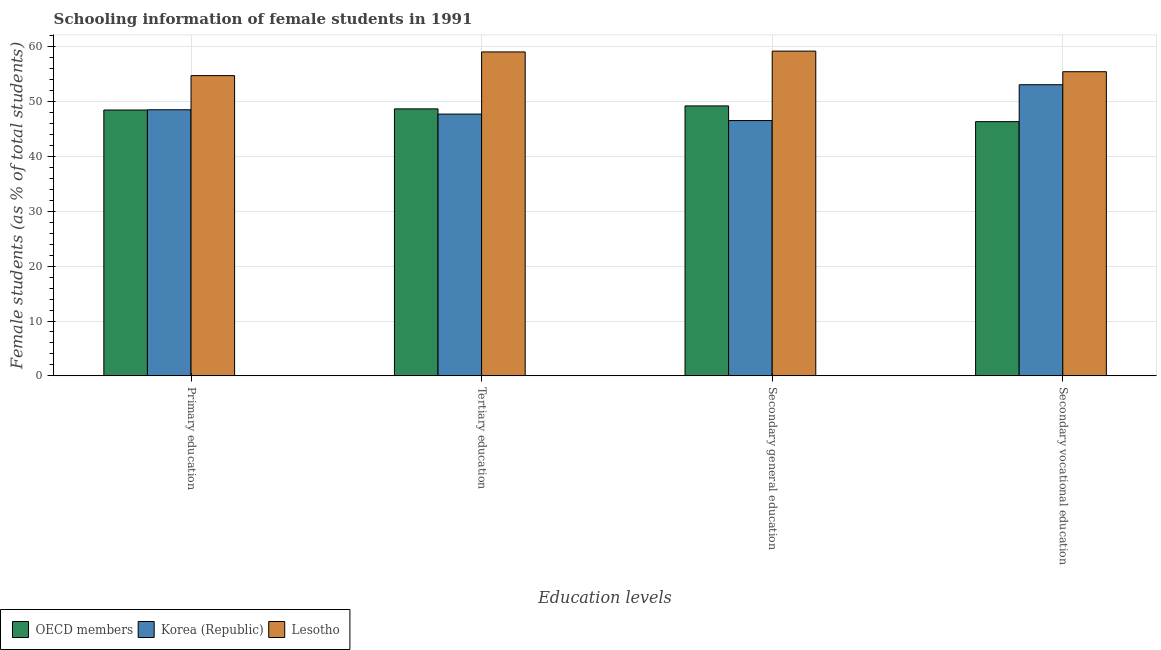How many different coloured bars are there?
Offer a terse response. 3. How many groups of bars are there?
Keep it short and to the point. 4. What is the label of the 1st group of bars from the left?
Keep it short and to the point. Primary education. What is the percentage of female students in secondary vocational education in Korea (Republic)?
Provide a succinct answer. 53.09. Across all countries, what is the maximum percentage of female students in secondary vocational education?
Make the answer very short. 55.46. Across all countries, what is the minimum percentage of female students in primary education?
Keep it short and to the point. 48.48. In which country was the percentage of female students in secondary vocational education maximum?
Offer a very short reply. Lesotho. What is the total percentage of female students in secondary education in the graph?
Provide a succinct answer. 154.99. What is the difference between the percentage of female students in primary education in OECD members and that in Lesotho?
Provide a succinct answer. -6.27. What is the difference between the percentage of female students in secondary education in OECD members and the percentage of female students in tertiary education in Korea (Republic)?
Your answer should be compact. 1.49. What is the average percentage of female students in secondary education per country?
Make the answer very short. 51.66. What is the difference between the percentage of female students in primary education and percentage of female students in tertiary education in OECD members?
Provide a succinct answer. -0.2. What is the ratio of the percentage of female students in tertiary education in Lesotho to that in OECD members?
Your answer should be compact. 1.21. Is the percentage of female students in primary education in OECD members less than that in Korea (Republic)?
Keep it short and to the point. Yes. What is the difference between the highest and the second highest percentage of female students in secondary vocational education?
Offer a very short reply. 2.37. What is the difference between the highest and the lowest percentage of female students in primary education?
Your response must be concise. 6.27. In how many countries, is the percentage of female students in primary education greater than the average percentage of female students in primary education taken over all countries?
Offer a very short reply. 1. Is the sum of the percentage of female students in secondary education in OECD members and Korea (Republic) greater than the maximum percentage of female students in tertiary education across all countries?
Make the answer very short. Yes. Is it the case that in every country, the sum of the percentage of female students in primary education and percentage of female students in secondary education is greater than the sum of percentage of female students in secondary vocational education and percentage of female students in tertiary education?
Provide a short and direct response. No. What does the 3rd bar from the left in Secondary general education represents?
Your response must be concise. Lesotho. What does the 2nd bar from the right in Secondary general education represents?
Provide a short and direct response. Korea (Republic). Is it the case that in every country, the sum of the percentage of female students in primary education and percentage of female students in tertiary education is greater than the percentage of female students in secondary education?
Provide a short and direct response. Yes. Are all the bars in the graph horizontal?
Provide a short and direct response. No. How many countries are there in the graph?
Your answer should be compact. 3. Where does the legend appear in the graph?
Make the answer very short. Bottom left. How are the legend labels stacked?
Your response must be concise. Horizontal. What is the title of the graph?
Your response must be concise. Schooling information of female students in 1991. What is the label or title of the X-axis?
Offer a very short reply. Education levels. What is the label or title of the Y-axis?
Make the answer very short. Female students (as % of total students). What is the Female students (as % of total students) in OECD members in Primary education?
Make the answer very short. 48.48. What is the Female students (as % of total students) of Korea (Republic) in Primary education?
Make the answer very short. 48.52. What is the Female students (as % of total students) of Lesotho in Primary education?
Ensure brevity in your answer.  54.75. What is the Female students (as % of total students) in OECD members in Tertiary education?
Offer a very short reply. 48.68. What is the Female students (as % of total students) in Korea (Republic) in Tertiary education?
Give a very brief answer. 47.73. What is the Female students (as % of total students) in Lesotho in Tertiary education?
Give a very brief answer. 59.06. What is the Female students (as % of total students) in OECD members in Secondary general education?
Make the answer very short. 49.22. What is the Female students (as % of total students) in Korea (Republic) in Secondary general education?
Offer a very short reply. 46.55. What is the Female students (as % of total students) of Lesotho in Secondary general education?
Provide a succinct answer. 59.21. What is the Female students (as % of total students) of OECD members in Secondary vocational education?
Keep it short and to the point. 46.35. What is the Female students (as % of total students) in Korea (Republic) in Secondary vocational education?
Give a very brief answer. 53.09. What is the Female students (as % of total students) of Lesotho in Secondary vocational education?
Your answer should be compact. 55.46. Across all Education levels, what is the maximum Female students (as % of total students) of OECD members?
Offer a very short reply. 49.22. Across all Education levels, what is the maximum Female students (as % of total students) in Korea (Republic)?
Provide a succinct answer. 53.09. Across all Education levels, what is the maximum Female students (as % of total students) in Lesotho?
Your answer should be compact. 59.21. Across all Education levels, what is the minimum Female students (as % of total students) of OECD members?
Provide a short and direct response. 46.35. Across all Education levels, what is the minimum Female students (as % of total students) of Korea (Republic)?
Ensure brevity in your answer.  46.55. Across all Education levels, what is the minimum Female students (as % of total students) of Lesotho?
Offer a very short reply. 54.75. What is the total Female students (as % of total students) in OECD members in the graph?
Ensure brevity in your answer.  192.73. What is the total Female students (as % of total students) of Korea (Republic) in the graph?
Your response must be concise. 195.89. What is the total Female students (as % of total students) of Lesotho in the graph?
Offer a terse response. 228.48. What is the difference between the Female students (as % of total students) in OECD members in Primary education and that in Tertiary education?
Your answer should be very brief. -0.2. What is the difference between the Female students (as % of total students) in Korea (Republic) in Primary education and that in Tertiary education?
Keep it short and to the point. 0.78. What is the difference between the Female students (as % of total students) in Lesotho in Primary education and that in Tertiary education?
Offer a very short reply. -4.32. What is the difference between the Female students (as % of total students) in OECD members in Primary education and that in Secondary general education?
Keep it short and to the point. -0.75. What is the difference between the Female students (as % of total students) of Korea (Republic) in Primary education and that in Secondary general education?
Offer a terse response. 1.97. What is the difference between the Female students (as % of total students) of Lesotho in Primary education and that in Secondary general education?
Your answer should be very brief. -4.47. What is the difference between the Female students (as % of total students) in OECD members in Primary education and that in Secondary vocational education?
Offer a very short reply. 2.12. What is the difference between the Female students (as % of total students) in Korea (Republic) in Primary education and that in Secondary vocational education?
Ensure brevity in your answer.  -4.57. What is the difference between the Female students (as % of total students) in Lesotho in Primary education and that in Secondary vocational education?
Make the answer very short. -0.71. What is the difference between the Female students (as % of total students) in OECD members in Tertiary education and that in Secondary general education?
Provide a short and direct response. -0.54. What is the difference between the Female students (as % of total students) of Korea (Republic) in Tertiary education and that in Secondary general education?
Make the answer very short. 1.18. What is the difference between the Female students (as % of total students) of Lesotho in Tertiary education and that in Secondary general education?
Offer a very short reply. -0.15. What is the difference between the Female students (as % of total students) in OECD members in Tertiary education and that in Secondary vocational education?
Offer a very short reply. 2.33. What is the difference between the Female students (as % of total students) of Korea (Republic) in Tertiary education and that in Secondary vocational education?
Offer a terse response. -5.35. What is the difference between the Female students (as % of total students) of Lesotho in Tertiary education and that in Secondary vocational education?
Your answer should be very brief. 3.61. What is the difference between the Female students (as % of total students) in OECD members in Secondary general education and that in Secondary vocational education?
Offer a very short reply. 2.87. What is the difference between the Female students (as % of total students) of Korea (Republic) in Secondary general education and that in Secondary vocational education?
Your answer should be compact. -6.53. What is the difference between the Female students (as % of total students) of Lesotho in Secondary general education and that in Secondary vocational education?
Provide a short and direct response. 3.76. What is the difference between the Female students (as % of total students) in OECD members in Primary education and the Female students (as % of total students) in Korea (Republic) in Tertiary education?
Give a very brief answer. 0.74. What is the difference between the Female students (as % of total students) of OECD members in Primary education and the Female students (as % of total students) of Lesotho in Tertiary education?
Your answer should be very brief. -10.59. What is the difference between the Female students (as % of total students) in Korea (Republic) in Primary education and the Female students (as % of total students) in Lesotho in Tertiary education?
Offer a terse response. -10.55. What is the difference between the Female students (as % of total students) of OECD members in Primary education and the Female students (as % of total students) of Korea (Republic) in Secondary general education?
Offer a very short reply. 1.92. What is the difference between the Female students (as % of total students) in OECD members in Primary education and the Female students (as % of total students) in Lesotho in Secondary general education?
Your response must be concise. -10.74. What is the difference between the Female students (as % of total students) in Korea (Republic) in Primary education and the Female students (as % of total students) in Lesotho in Secondary general education?
Give a very brief answer. -10.7. What is the difference between the Female students (as % of total students) of OECD members in Primary education and the Female students (as % of total students) of Korea (Republic) in Secondary vocational education?
Give a very brief answer. -4.61. What is the difference between the Female students (as % of total students) in OECD members in Primary education and the Female students (as % of total students) in Lesotho in Secondary vocational education?
Provide a short and direct response. -6.98. What is the difference between the Female students (as % of total students) in Korea (Republic) in Primary education and the Female students (as % of total students) in Lesotho in Secondary vocational education?
Your answer should be compact. -6.94. What is the difference between the Female students (as % of total students) in OECD members in Tertiary education and the Female students (as % of total students) in Korea (Republic) in Secondary general education?
Your answer should be very brief. 2.13. What is the difference between the Female students (as % of total students) in OECD members in Tertiary education and the Female students (as % of total students) in Lesotho in Secondary general education?
Your answer should be very brief. -10.53. What is the difference between the Female students (as % of total students) in Korea (Republic) in Tertiary education and the Female students (as % of total students) in Lesotho in Secondary general education?
Offer a terse response. -11.48. What is the difference between the Female students (as % of total students) in OECD members in Tertiary education and the Female students (as % of total students) in Korea (Republic) in Secondary vocational education?
Your answer should be very brief. -4.4. What is the difference between the Female students (as % of total students) in OECD members in Tertiary education and the Female students (as % of total students) in Lesotho in Secondary vocational education?
Offer a very short reply. -6.78. What is the difference between the Female students (as % of total students) in Korea (Republic) in Tertiary education and the Female students (as % of total students) in Lesotho in Secondary vocational education?
Your response must be concise. -7.73. What is the difference between the Female students (as % of total students) of OECD members in Secondary general education and the Female students (as % of total students) of Korea (Republic) in Secondary vocational education?
Ensure brevity in your answer.  -3.86. What is the difference between the Female students (as % of total students) of OECD members in Secondary general education and the Female students (as % of total students) of Lesotho in Secondary vocational education?
Make the answer very short. -6.24. What is the difference between the Female students (as % of total students) in Korea (Republic) in Secondary general education and the Female students (as % of total students) in Lesotho in Secondary vocational education?
Ensure brevity in your answer.  -8.91. What is the average Female students (as % of total students) of OECD members per Education levels?
Your response must be concise. 48.18. What is the average Female students (as % of total students) in Korea (Republic) per Education levels?
Offer a very short reply. 48.97. What is the average Female students (as % of total students) of Lesotho per Education levels?
Your answer should be very brief. 57.12. What is the difference between the Female students (as % of total students) of OECD members and Female students (as % of total students) of Korea (Republic) in Primary education?
Your answer should be compact. -0.04. What is the difference between the Female students (as % of total students) in OECD members and Female students (as % of total students) in Lesotho in Primary education?
Provide a succinct answer. -6.27. What is the difference between the Female students (as % of total students) in Korea (Republic) and Female students (as % of total students) in Lesotho in Primary education?
Offer a terse response. -6.23. What is the difference between the Female students (as % of total students) in OECD members and Female students (as % of total students) in Korea (Republic) in Tertiary education?
Your answer should be compact. 0.95. What is the difference between the Female students (as % of total students) of OECD members and Female students (as % of total students) of Lesotho in Tertiary education?
Keep it short and to the point. -10.38. What is the difference between the Female students (as % of total students) of Korea (Republic) and Female students (as % of total students) of Lesotho in Tertiary education?
Keep it short and to the point. -11.33. What is the difference between the Female students (as % of total students) in OECD members and Female students (as % of total students) in Korea (Republic) in Secondary general education?
Make the answer very short. 2.67. What is the difference between the Female students (as % of total students) of OECD members and Female students (as % of total students) of Lesotho in Secondary general education?
Keep it short and to the point. -9.99. What is the difference between the Female students (as % of total students) of Korea (Republic) and Female students (as % of total students) of Lesotho in Secondary general education?
Provide a succinct answer. -12.66. What is the difference between the Female students (as % of total students) of OECD members and Female students (as % of total students) of Korea (Republic) in Secondary vocational education?
Offer a very short reply. -6.73. What is the difference between the Female students (as % of total students) of OECD members and Female students (as % of total students) of Lesotho in Secondary vocational education?
Make the answer very short. -9.1. What is the difference between the Female students (as % of total students) in Korea (Republic) and Female students (as % of total students) in Lesotho in Secondary vocational education?
Provide a succinct answer. -2.37. What is the ratio of the Female students (as % of total students) in Korea (Republic) in Primary education to that in Tertiary education?
Give a very brief answer. 1.02. What is the ratio of the Female students (as % of total students) in Lesotho in Primary education to that in Tertiary education?
Offer a very short reply. 0.93. What is the ratio of the Female students (as % of total students) of Korea (Republic) in Primary education to that in Secondary general education?
Your answer should be compact. 1.04. What is the ratio of the Female students (as % of total students) in Lesotho in Primary education to that in Secondary general education?
Your answer should be compact. 0.92. What is the ratio of the Female students (as % of total students) of OECD members in Primary education to that in Secondary vocational education?
Offer a terse response. 1.05. What is the ratio of the Female students (as % of total students) of Korea (Republic) in Primary education to that in Secondary vocational education?
Give a very brief answer. 0.91. What is the ratio of the Female students (as % of total students) of Lesotho in Primary education to that in Secondary vocational education?
Make the answer very short. 0.99. What is the ratio of the Female students (as % of total students) in Korea (Republic) in Tertiary education to that in Secondary general education?
Your response must be concise. 1.03. What is the ratio of the Female students (as % of total students) in Lesotho in Tertiary education to that in Secondary general education?
Your answer should be compact. 1. What is the ratio of the Female students (as % of total students) of OECD members in Tertiary education to that in Secondary vocational education?
Your response must be concise. 1.05. What is the ratio of the Female students (as % of total students) of Korea (Republic) in Tertiary education to that in Secondary vocational education?
Your answer should be compact. 0.9. What is the ratio of the Female students (as % of total students) of Lesotho in Tertiary education to that in Secondary vocational education?
Provide a succinct answer. 1.06. What is the ratio of the Female students (as % of total students) of OECD members in Secondary general education to that in Secondary vocational education?
Keep it short and to the point. 1.06. What is the ratio of the Female students (as % of total students) in Korea (Republic) in Secondary general education to that in Secondary vocational education?
Provide a succinct answer. 0.88. What is the ratio of the Female students (as % of total students) of Lesotho in Secondary general education to that in Secondary vocational education?
Your answer should be very brief. 1.07. What is the difference between the highest and the second highest Female students (as % of total students) in OECD members?
Keep it short and to the point. 0.54. What is the difference between the highest and the second highest Female students (as % of total students) of Korea (Republic)?
Your response must be concise. 4.57. What is the difference between the highest and the second highest Female students (as % of total students) of Lesotho?
Offer a very short reply. 0.15. What is the difference between the highest and the lowest Female students (as % of total students) of OECD members?
Give a very brief answer. 2.87. What is the difference between the highest and the lowest Female students (as % of total students) in Korea (Republic)?
Provide a succinct answer. 6.53. What is the difference between the highest and the lowest Female students (as % of total students) in Lesotho?
Your answer should be compact. 4.47. 